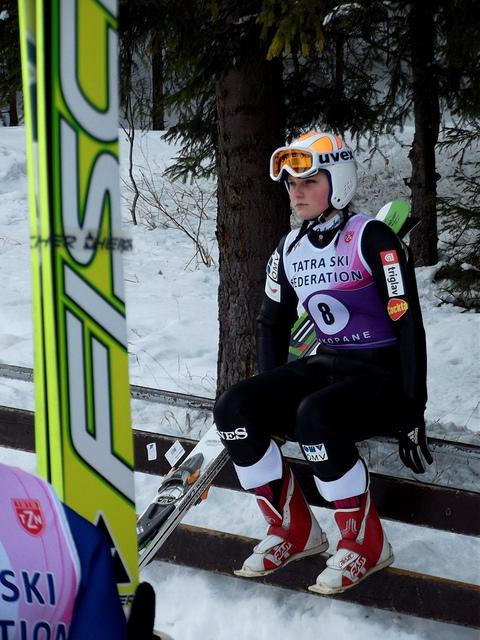What is the child wearing? ski suit 